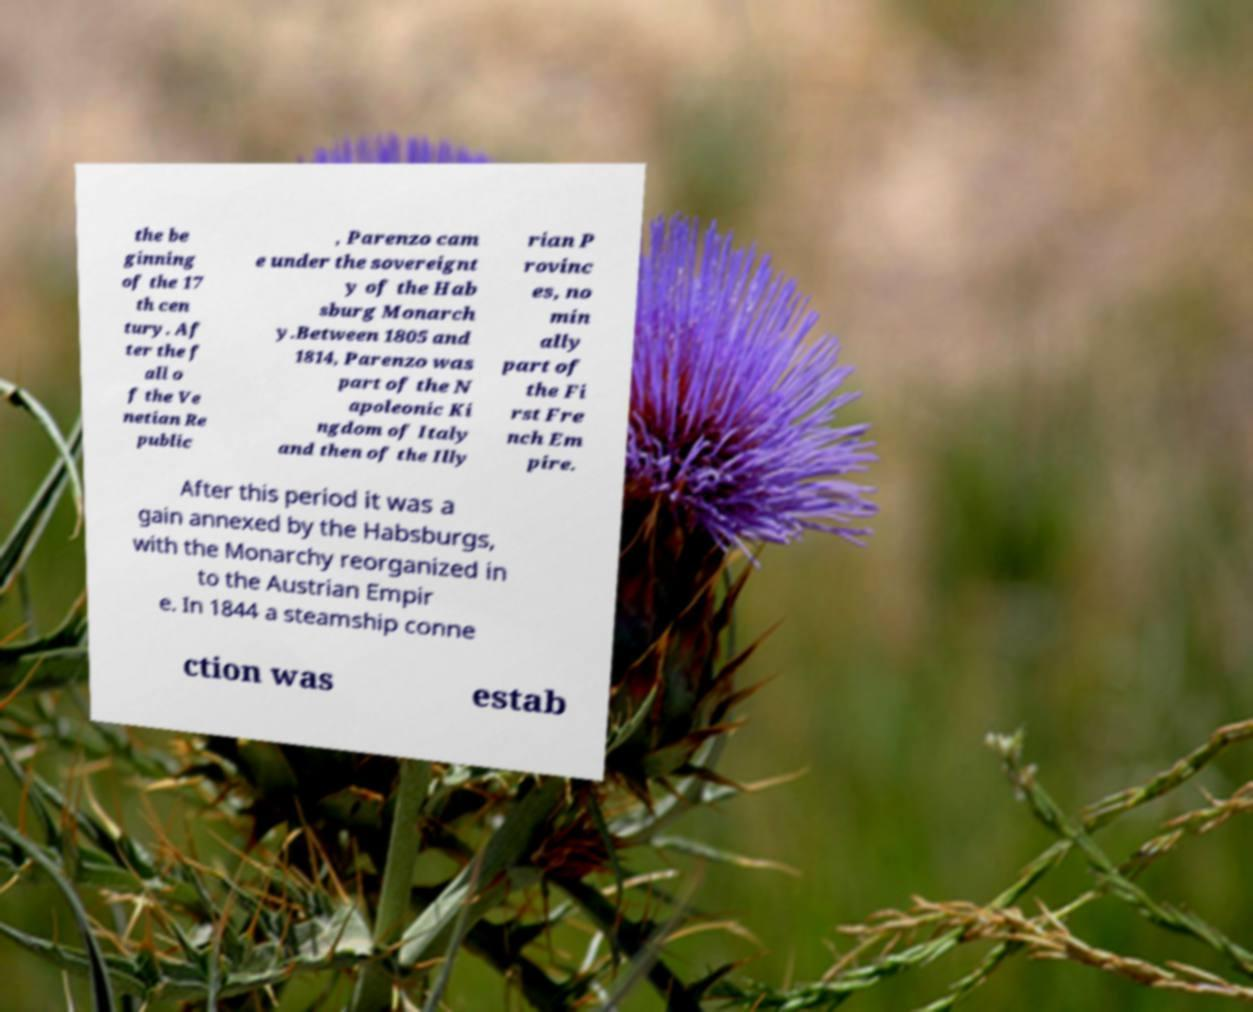For documentation purposes, I need the text within this image transcribed. Could you provide that? the be ginning of the 17 th cen tury. Af ter the f all o f the Ve netian Re public , Parenzo cam e under the sovereignt y of the Hab sburg Monarch y.Between 1805 and 1814, Parenzo was part of the N apoleonic Ki ngdom of Italy and then of the Illy rian P rovinc es, no min ally part of the Fi rst Fre nch Em pire. After this period it was a gain annexed by the Habsburgs, with the Monarchy reorganized in to the Austrian Empir e. In 1844 a steamship conne ction was estab 